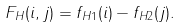Convert formula to latex. <formula><loc_0><loc_0><loc_500><loc_500>F _ { H } ( i , j ) = f _ { H 1 } ( i ) - f _ { H 2 } ( j ) .</formula> 